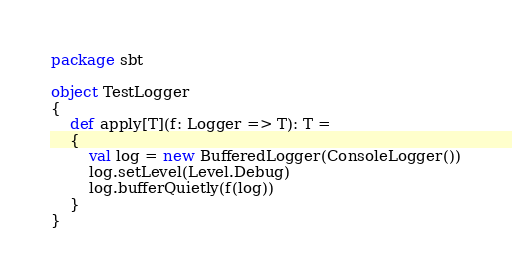Convert code to text. <code><loc_0><loc_0><loc_500><loc_500><_Scala_>package sbt

object TestLogger
{
	def apply[T](f: Logger => T): T =
	{
		val log = new BufferedLogger(ConsoleLogger())
		log.setLevel(Level.Debug)
		log.bufferQuietly(f(log))
	}
}</code> 